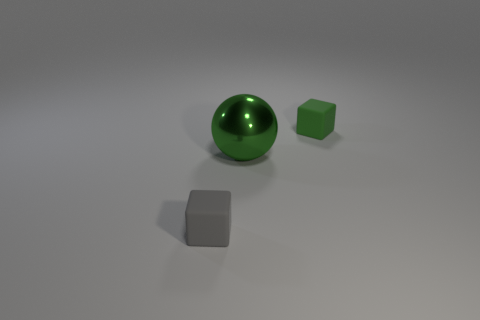Add 3 metal things. How many objects exist? 6 Subtract all cubes. How many objects are left? 1 Add 3 small green rubber cubes. How many small green rubber cubes are left? 4 Add 2 gray blocks. How many gray blocks exist? 3 Subtract 0 yellow cubes. How many objects are left? 3 Subtract 1 blocks. How many blocks are left? 1 Subtract all yellow balls. Subtract all yellow cylinders. How many balls are left? 1 Subtract all purple cylinders. How many purple cubes are left? 0 Subtract all blue shiny blocks. Subtract all gray rubber blocks. How many objects are left? 2 